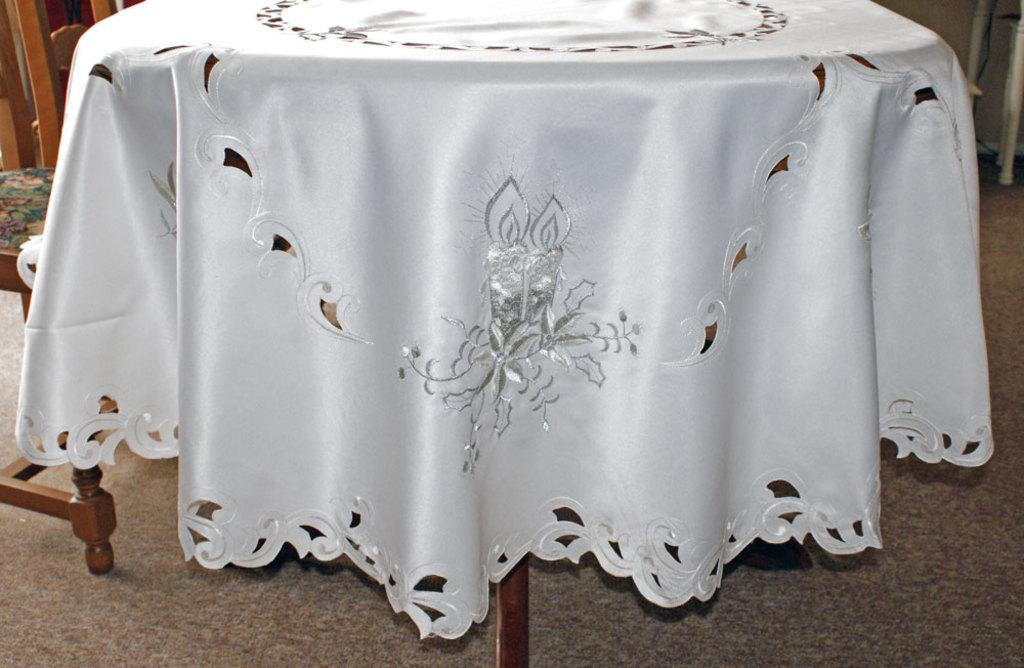What type of furniture is present in the image? There is a table in the image. What is covering the table? There is a white cloth on the table. What else can be seen on the floor in the image? There are chairs on the floor in the image. How far away are the friends in the image? There is no reference to friends in the image, so it is not possible to determine their distance from each other. 